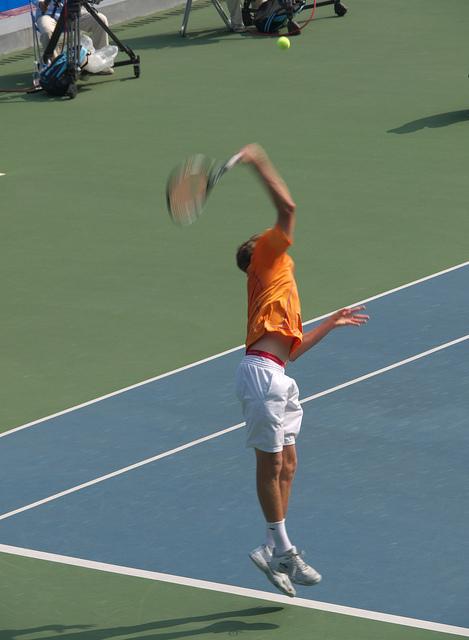What color is he standing on?
Be succinct. Green. What color stands out?
Concise answer only. Orange. Did he miss the ball?
Short answer required. No. What sport is being played?
Short answer required. Tennis. 